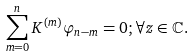Convert formula to latex. <formula><loc_0><loc_0><loc_500><loc_500>\sum _ { m = 0 } ^ { n } K ^ { ( m ) } \varphi _ { n - m } = 0 ; \forall z \in \mathbb { C } .</formula> 